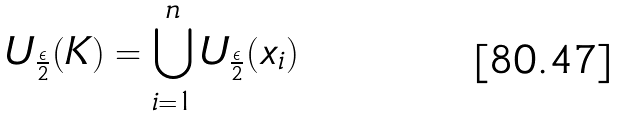Convert formula to latex. <formula><loc_0><loc_0><loc_500><loc_500>U _ { \frac { \epsilon } { 2 } } ( K ) = \bigcup _ { i = 1 } ^ { n } U _ { \frac { \epsilon } { 2 } } ( x _ { i } )</formula> 